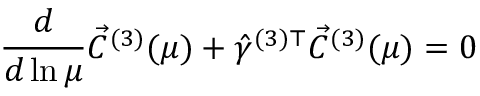<formula> <loc_0><loc_0><loc_500><loc_500>\frac { d } { d \ln \mu } \vec { C } ^ { ( 3 ) } ( \mu ) + \hat { \gamma } ^ { ( 3 ) \top } \vec { C } ^ { ( 3 ) } ( \mu ) = 0</formula> 